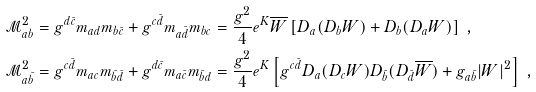Convert formula to latex. <formula><loc_0><loc_0><loc_500><loc_500>\mathcal { M } _ { a b } ^ { 2 } & = g ^ { d \bar { c } } m _ { a d } m _ { b \bar { c } } + g ^ { c \bar { d } } m _ { a \bar { d } } m _ { b c } = \frac { g ^ { 2 } } { 4 } e ^ { K } \overline { W } \left [ D _ { a } ( D _ { b } W ) + D _ { b } ( D _ { a } W ) \right ] \ , \\ \mathcal { M } ^ { 2 } _ { a \bar { b } } & = g ^ { c \bar { d } } m _ { a c } m _ { \bar { b } \bar { d } } + g ^ { d \bar { c } } m _ { a \bar { c } } m _ { \bar { b } d } = \frac { g ^ { 2 } } { 4 } e ^ { K } \left [ g ^ { c \bar { d } } D _ { a } ( D _ { c } W ) D _ { \bar { b } } ( D _ { \bar { d } } \overline { W } ) + g _ { a \bar { b } } | W | ^ { 2 } \right ] \ ,</formula> 